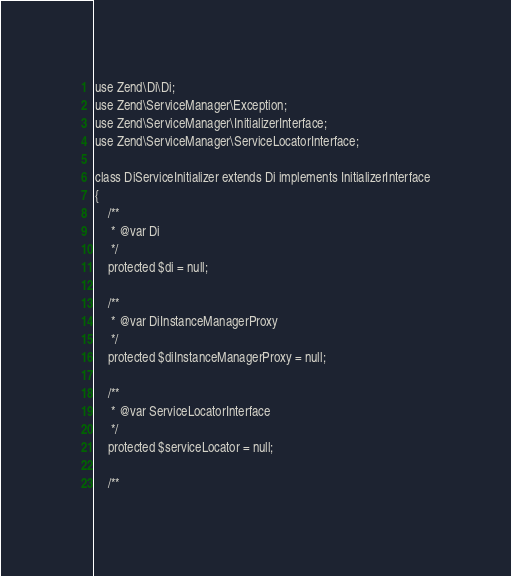<code> <loc_0><loc_0><loc_500><loc_500><_PHP_>
use Zend\Di\Di;
use Zend\ServiceManager\Exception;
use Zend\ServiceManager\InitializerInterface;
use Zend\ServiceManager\ServiceLocatorInterface;

class DiServiceInitializer extends Di implements InitializerInterface
{
    /**
     * @var Di
     */
    protected $di = null;

    /**
     * @var DiInstanceManagerProxy
     */
    protected $diInstanceManagerProxy = null;

    /**
     * @var ServiceLocatorInterface
     */
    protected $serviceLocator = null;

    /**</code> 